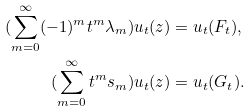Convert formula to latex. <formula><loc_0><loc_0><loc_500><loc_500>( \sum _ { m = 0 } ^ { \infty } ( - 1 ) ^ { m } t ^ { m } \lambda _ { m } ) u _ { t } ( z ) & = u _ { t } ( F _ { t } ) , \\ ( \sum _ { m = 0 } ^ { \infty } t ^ { m } s _ { m } ) u _ { t } ( z ) & = u _ { t } ( G _ { t } ) .</formula> 